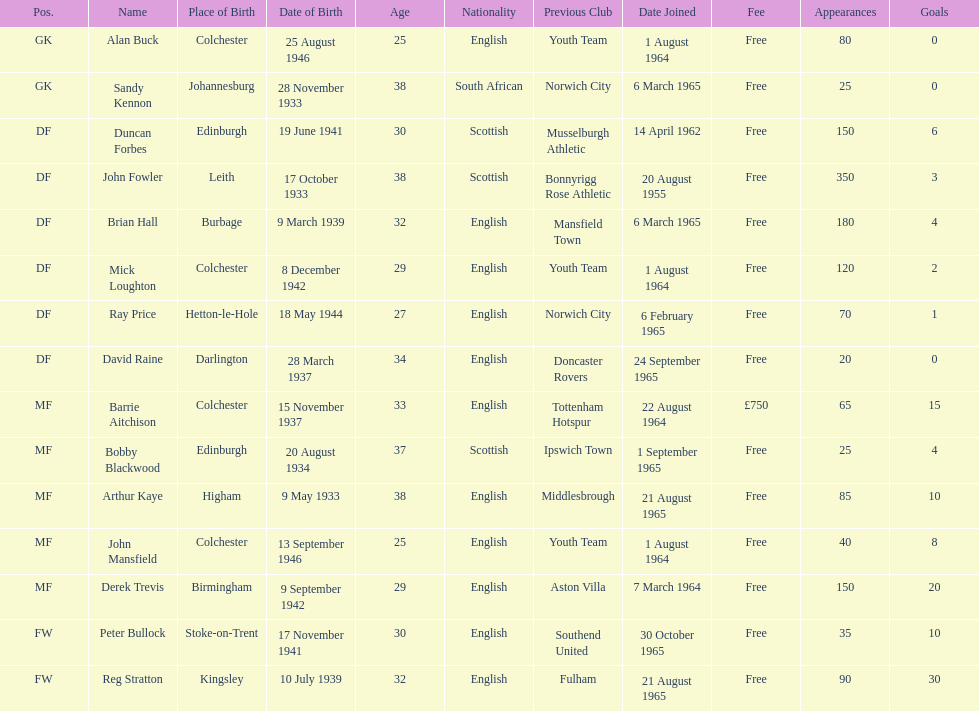How many players are listed as df? 6. 